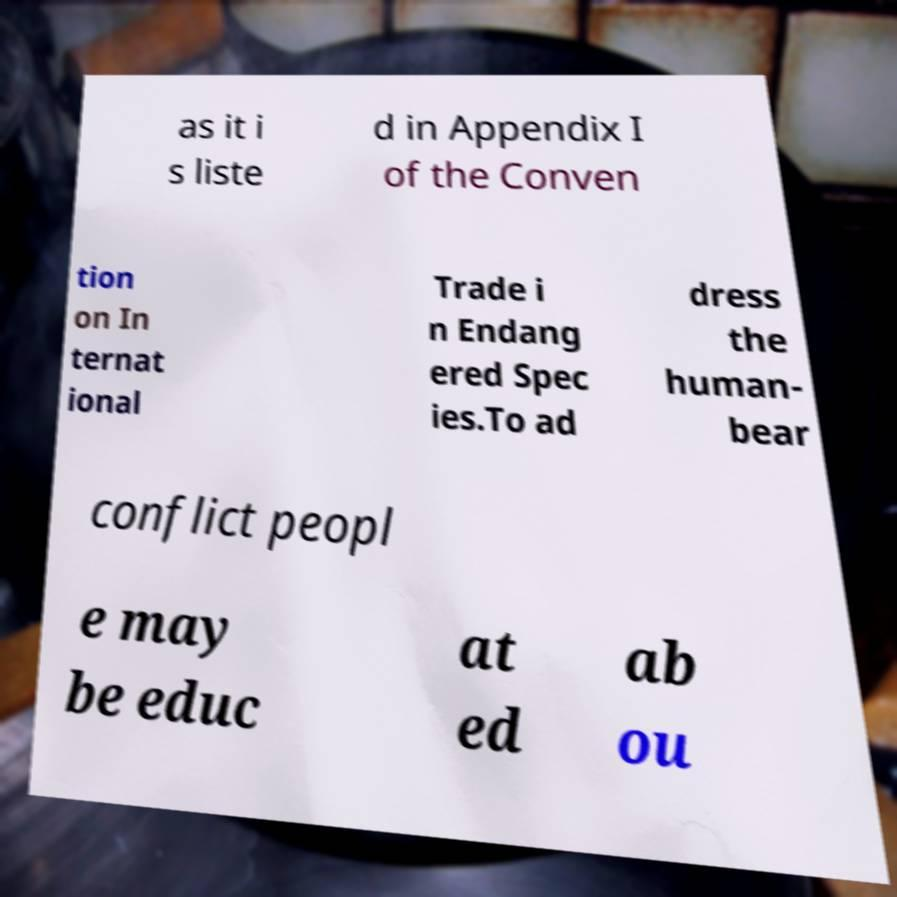Can you accurately transcribe the text from the provided image for me? as it i s liste d in Appendix I of the Conven tion on In ternat ional Trade i n Endang ered Spec ies.To ad dress the human- bear conflict peopl e may be educ at ed ab ou 